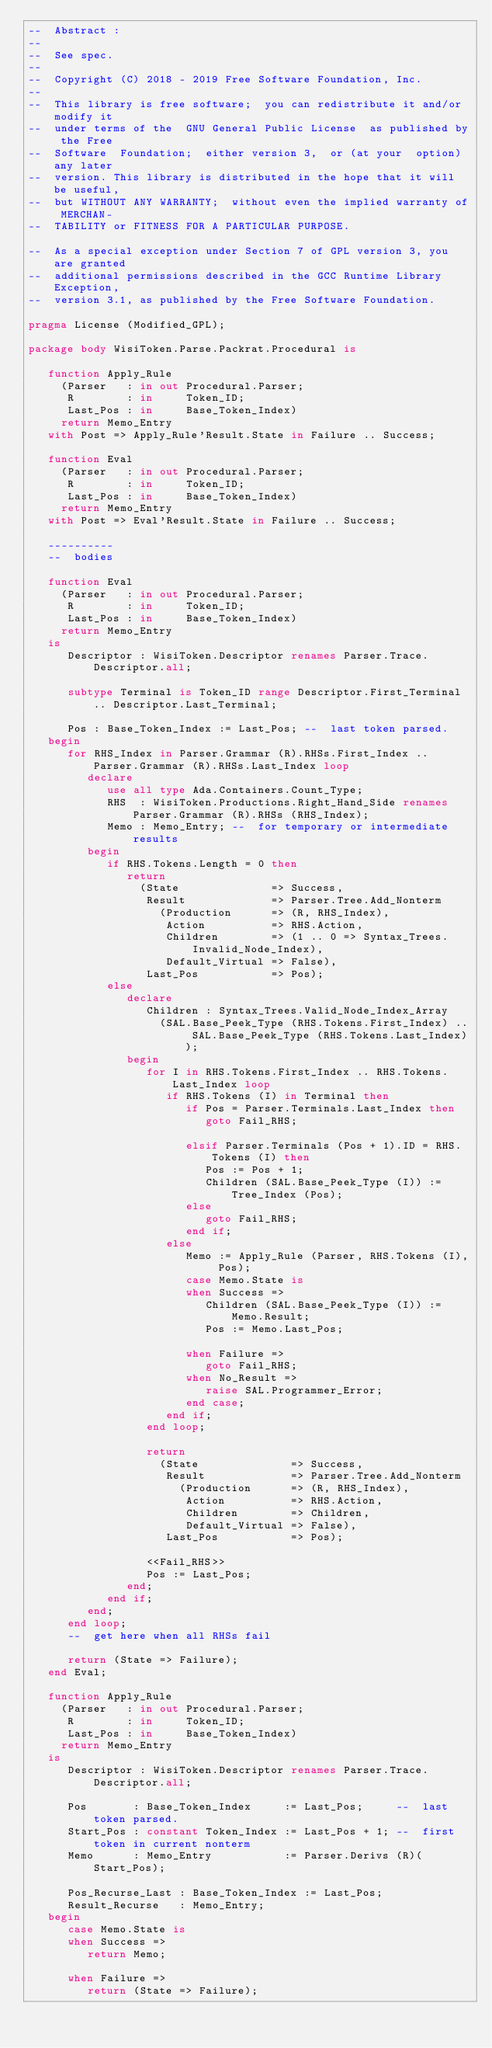Convert code to text. <code><loc_0><loc_0><loc_500><loc_500><_Ada_>--  Abstract :
--
--  See spec.
--
--  Copyright (C) 2018 - 2019 Free Software Foundation, Inc.
--
--  This library is free software;  you can redistribute it and/or modify it
--  under terms of the  GNU General Public License  as published by the Free
--  Software  Foundation;  either version 3,  or (at your  option) any later
--  version. This library is distributed in the hope that it will be useful,
--  but WITHOUT ANY WARRANTY;  without even the implied warranty of MERCHAN-
--  TABILITY or FITNESS FOR A PARTICULAR PURPOSE.

--  As a special exception under Section 7 of GPL version 3, you are granted
--  additional permissions described in the GCC Runtime Library Exception,
--  version 3.1, as published by the Free Software Foundation.

pragma License (Modified_GPL);

package body WisiToken.Parse.Packrat.Procedural is

   function Apply_Rule
     (Parser   : in out Procedural.Parser;
      R        : in     Token_ID;
      Last_Pos : in     Base_Token_Index)
     return Memo_Entry
   with Post => Apply_Rule'Result.State in Failure .. Success;

   function Eval
     (Parser   : in out Procedural.Parser;
      R        : in     Token_ID;
      Last_Pos : in     Base_Token_Index)
     return Memo_Entry
   with Post => Eval'Result.State in Failure .. Success;

   ----------
   --  bodies

   function Eval
     (Parser   : in out Procedural.Parser;
      R        : in     Token_ID;
      Last_Pos : in     Base_Token_Index)
     return Memo_Entry
   is
      Descriptor : WisiToken.Descriptor renames Parser.Trace.Descriptor.all;

      subtype Terminal is Token_ID range Descriptor.First_Terminal .. Descriptor.Last_Terminal;

      Pos : Base_Token_Index := Last_Pos; --  last token parsed.
   begin
      for RHS_Index in Parser.Grammar (R).RHSs.First_Index .. Parser.Grammar (R).RHSs.Last_Index loop
         declare
            use all type Ada.Containers.Count_Type;
            RHS  : WisiToken.Productions.Right_Hand_Side renames Parser.Grammar (R).RHSs (RHS_Index);
            Memo : Memo_Entry; --  for temporary or intermediate results
         begin
            if RHS.Tokens.Length = 0 then
               return
                 (State              => Success,
                  Result             => Parser.Tree.Add_Nonterm
                    (Production      => (R, RHS_Index),
                     Action          => RHS.Action,
                     Children        => (1 .. 0 => Syntax_Trees.Invalid_Node_Index),
                     Default_Virtual => False),
                  Last_Pos           => Pos);
            else
               declare
                  Children : Syntax_Trees.Valid_Node_Index_Array
                    (SAL.Base_Peek_Type (RHS.Tokens.First_Index) .. SAL.Base_Peek_Type (RHS.Tokens.Last_Index));
               begin
                  for I in RHS.Tokens.First_Index .. RHS.Tokens.Last_Index loop
                     if RHS.Tokens (I) in Terminal then
                        if Pos = Parser.Terminals.Last_Index then
                           goto Fail_RHS;

                        elsif Parser.Terminals (Pos + 1).ID = RHS.Tokens (I) then
                           Pos := Pos + 1;
                           Children (SAL.Base_Peek_Type (I)) := Tree_Index (Pos);
                        else
                           goto Fail_RHS;
                        end if;
                     else
                        Memo := Apply_Rule (Parser, RHS.Tokens (I), Pos);
                        case Memo.State is
                        when Success =>
                           Children (SAL.Base_Peek_Type (I)) := Memo.Result;
                           Pos := Memo.Last_Pos;

                        when Failure =>
                           goto Fail_RHS;
                        when No_Result =>
                           raise SAL.Programmer_Error;
                        end case;
                     end if;
                  end loop;

                  return
                    (State              => Success,
                     Result             => Parser.Tree.Add_Nonterm
                       (Production      => (R, RHS_Index),
                        Action          => RHS.Action,
                        Children        => Children,
                        Default_Virtual => False),
                     Last_Pos           => Pos);

                  <<Fail_RHS>>
                  Pos := Last_Pos;
               end;
            end if;
         end;
      end loop;
      --  get here when all RHSs fail

      return (State => Failure);
   end Eval;

   function Apply_Rule
     (Parser   : in out Procedural.Parser;
      R        : in     Token_ID;
      Last_Pos : in     Base_Token_Index)
     return Memo_Entry
   is
      Descriptor : WisiToken.Descriptor renames Parser.Trace.Descriptor.all;

      Pos       : Base_Token_Index     := Last_Pos;     --  last token parsed.
      Start_Pos : constant Token_Index := Last_Pos + 1; --  first token in current nonterm
      Memo      : Memo_Entry           := Parser.Derivs (R)(Start_Pos);

      Pos_Recurse_Last : Base_Token_Index := Last_Pos;
      Result_Recurse   : Memo_Entry;
   begin
      case Memo.State is
      when Success =>
         return Memo;

      when Failure =>
         return (State => Failure);
</code> 